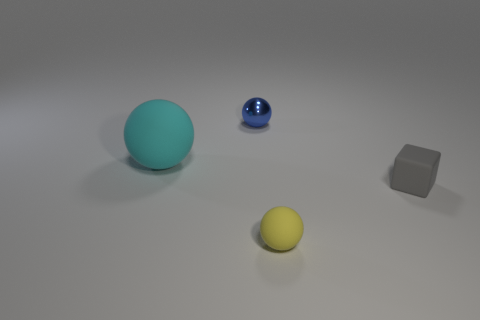Subtract all matte spheres. How many spheres are left? 1 Add 2 cyan spheres. How many objects exist? 6 Subtract all cubes. How many objects are left? 3 Subtract all brown spheres. Subtract all blue blocks. How many spheres are left? 3 Subtract 0 purple cylinders. How many objects are left? 4 Subtract all green rubber balls. Subtract all big things. How many objects are left? 3 Add 3 rubber balls. How many rubber balls are left? 5 Add 3 small cyan metallic balls. How many small cyan metallic balls exist? 3 